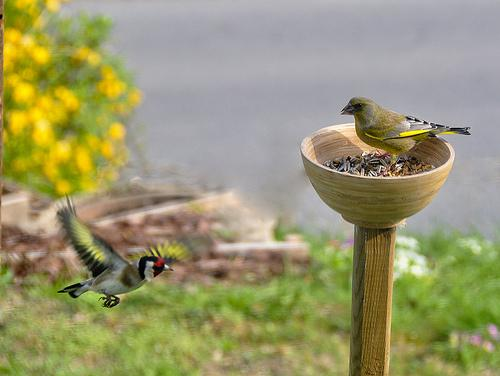Question: who is flying?
Choices:
A. The black bird.
B. The blue bird.
C. The bird with red on it's head.
D. The yellow bird.
Answer with the letter. Answer: C Question: what is the bird with red on it doing?
Choices:
A. Flying.
B. Perched on a wire.
C. Perched on a tree limb.
D. Perched on a fence.
Answer with the letter. Answer: A Question: how many birds are visible?
Choices:
A. Two.
B. Three.
C. Six.
D. Nine.
Answer with the letter. Answer: A 